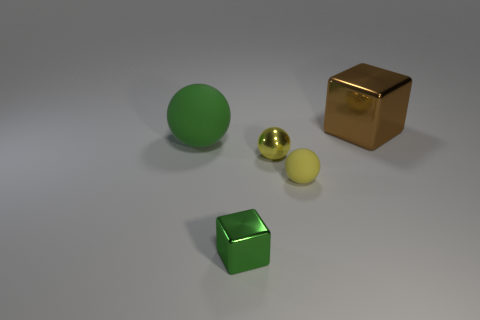Subtract all yellow cylinders. How many yellow balls are left? 2 Add 4 large green matte cylinders. How many objects exist? 9 Subtract all yellow shiny spheres. How many spheres are left? 2 Subtract all green spheres. How many spheres are left? 2 Subtract all balls. How many objects are left? 2 Add 4 yellow balls. How many yellow balls exist? 6 Subtract 0 cyan cubes. How many objects are left? 5 Subtract all red blocks. Subtract all red cylinders. How many blocks are left? 2 Subtract all tiny yellow things. Subtract all tiny green cubes. How many objects are left? 2 Add 3 big green spheres. How many big green spheres are left? 4 